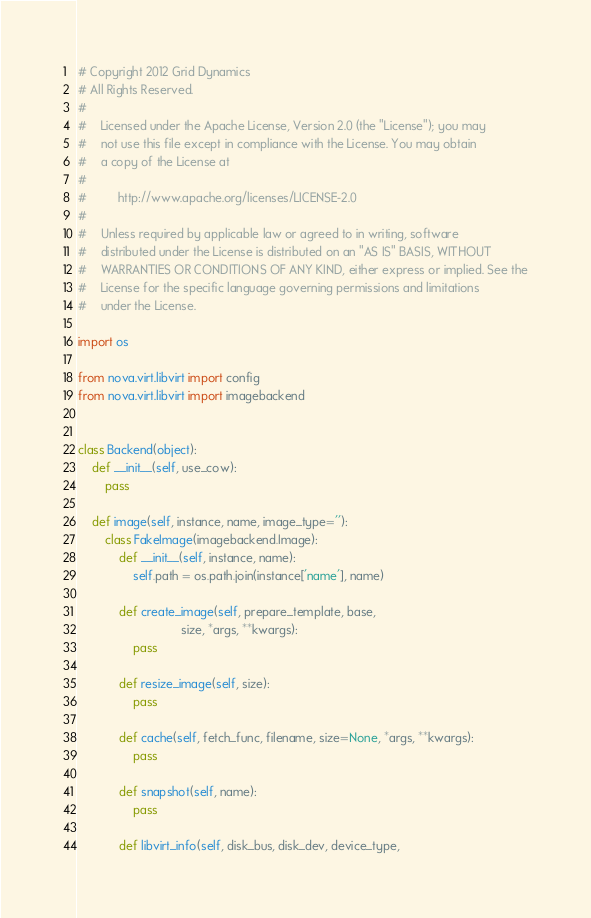<code> <loc_0><loc_0><loc_500><loc_500><_Python_># Copyright 2012 Grid Dynamics
# All Rights Reserved.
#
#    Licensed under the Apache License, Version 2.0 (the "License"); you may
#    not use this file except in compliance with the License. You may obtain
#    a copy of the License at
#
#         http://www.apache.org/licenses/LICENSE-2.0
#
#    Unless required by applicable law or agreed to in writing, software
#    distributed under the License is distributed on an "AS IS" BASIS, WITHOUT
#    WARRANTIES OR CONDITIONS OF ANY KIND, either express or implied. See the
#    License for the specific language governing permissions and limitations
#    under the License.

import os

from nova.virt.libvirt import config
from nova.virt.libvirt import imagebackend


class Backend(object):
    def __init__(self, use_cow):
        pass

    def image(self, instance, name, image_type=''):
        class FakeImage(imagebackend.Image):
            def __init__(self, instance, name):
                self.path = os.path.join(instance['name'], name)

            def create_image(self, prepare_template, base,
                              size, *args, **kwargs):
                pass

            def resize_image(self, size):
                pass

            def cache(self, fetch_func, filename, size=None, *args, **kwargs):
                pass

            def snapshot(self, name):
                pass

            def libvirt_info(self, disk_bus, disk_dev, device_type,</code> 